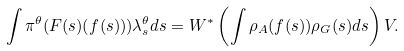Convert formula to latex. <formula><loc_0><loc_0><loc_500><loc_500>\int \pi ^ { \theta } ( F ( s ) ( f ( s ) ) ) \lambda _ { s } ^ { \theta } d s = W ^ { * } \left ( \int \rho _ { A } ( f ( s ) ) \rho _ { G } ( s ) d s \right ) V .</formula> 